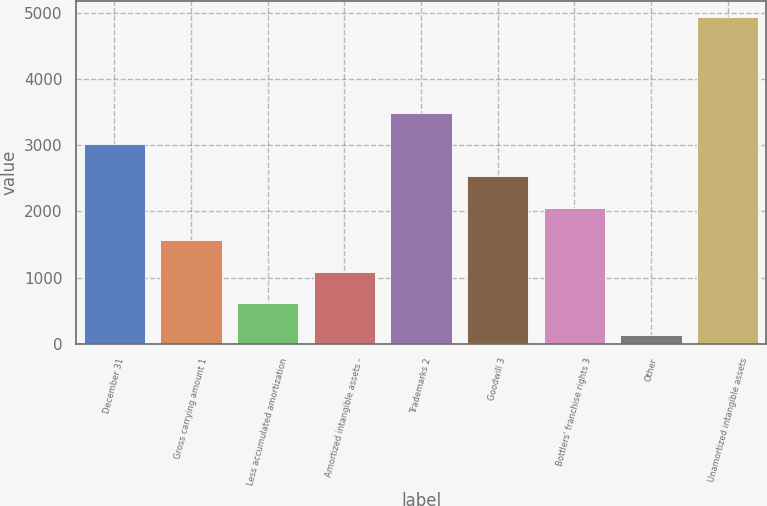Convert chart. <chart><loc_0><loc_0><loc_500><loc_500><bar_chart><fcel>December 31<fcel>Gross carrying amount 1<fcel>Less accumulated amortization<fcel>Amortized intangible assets -<fcel>Trademarks 2<fcel>Goodwill 3<fcel>Bottlers' franchise rights 3<fcel>Other<fcel>Unamortized intangible assets<nl><fcel>3014.2<fcel>1572.1<fcel>610.7<fcel>1091.4<fcel>3494.9<fcel>2533.5<fcel>2052.8<fcel>130<fcel>4937<nl></chart> 